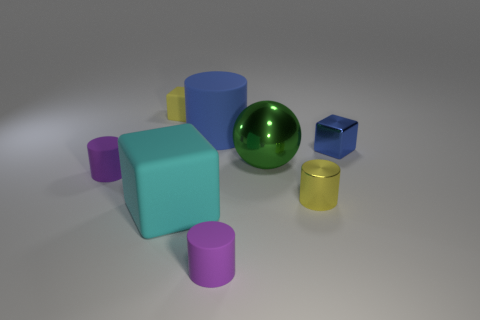Subtract all brown cylinders. Subtract all brown balls. How many cylinders are left? 4 Add 1 cyan rubber things. How many objects exist? 9 Subtract all balls. How many objects are left? 7 Add 2 rubber blocks. How many rubber blocks exist? 4 Subtract 0 brown spheres. How many objects are left? 8 Subtract all tiny gray objects. Subtract all metallic things. How many objects are left? 5 Add 3 yellow rubber cubes. How many yellow rubber cubes are left? 4 